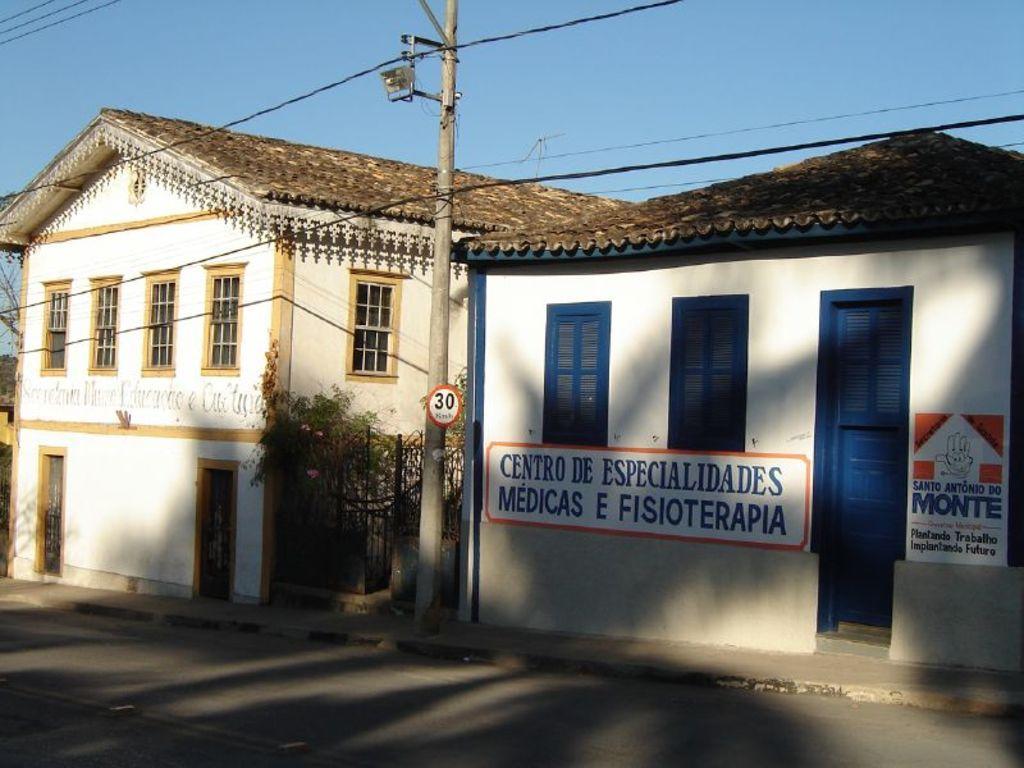In one or two sentences, can you explain what this image depicts? In this image I can see the houses which are in blue, brown color. And I can see some stickers to the house. I can also see the current pole in-between the house. And there is a plant can be seen. In-front of the house there is a road and in the back I can see the sky. 